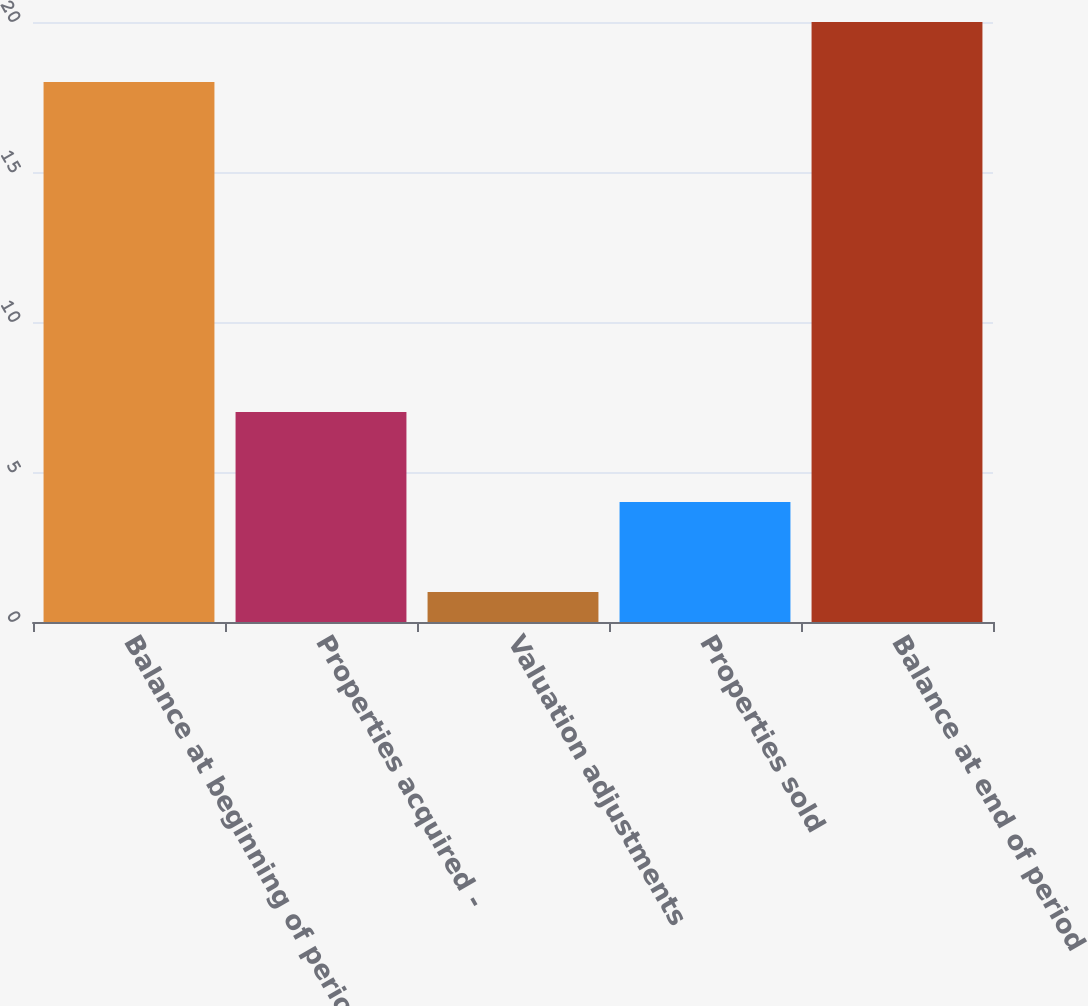Convert chart. <chart><loc_0><loc_0><loc_500><loc_500><bar_chart><fcel>Balance at beginning of period<fcel>Properties acquired -<fcel>Valuation adjustments<fcel>Properties sold<fcel>Balance at end of period<nl><fcel>18<fcel>7<fcel>1<fcel>4<fcel>20<nl></chart> 